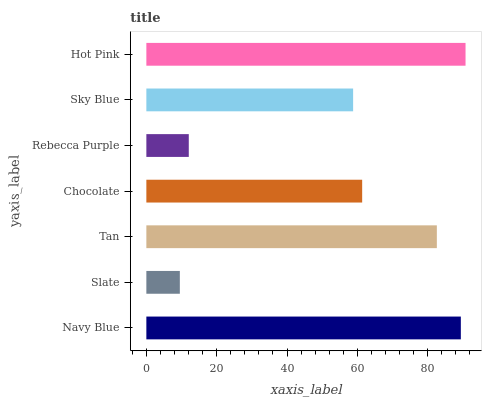Is Slate the minimum?
Answer yes or no. Yes. Is Hot Pink the maximum?
Answer yes or no. Yes. Is Tan the minimum?
Answer yes or no. No. Is Tan the maximum?
Answer yes or no. No. Is Tan greater than Slate?
Answer yes or no. Yes. Is Slate less than Tan?
Answer yes or no. Yes. Is Slate greater than Tan?
Answer yes or no. No. Is Tan less than Slate?
Answer yes or no. No. Is Chocolate the high median?
Answer yes or no. Yes. Is Chocolate the low median?
Answer yes or no. Yes. Is Tan the high median?
Answer yes or no. No. Is Rebecca Purple the low median?
Answer yes or no. No. 